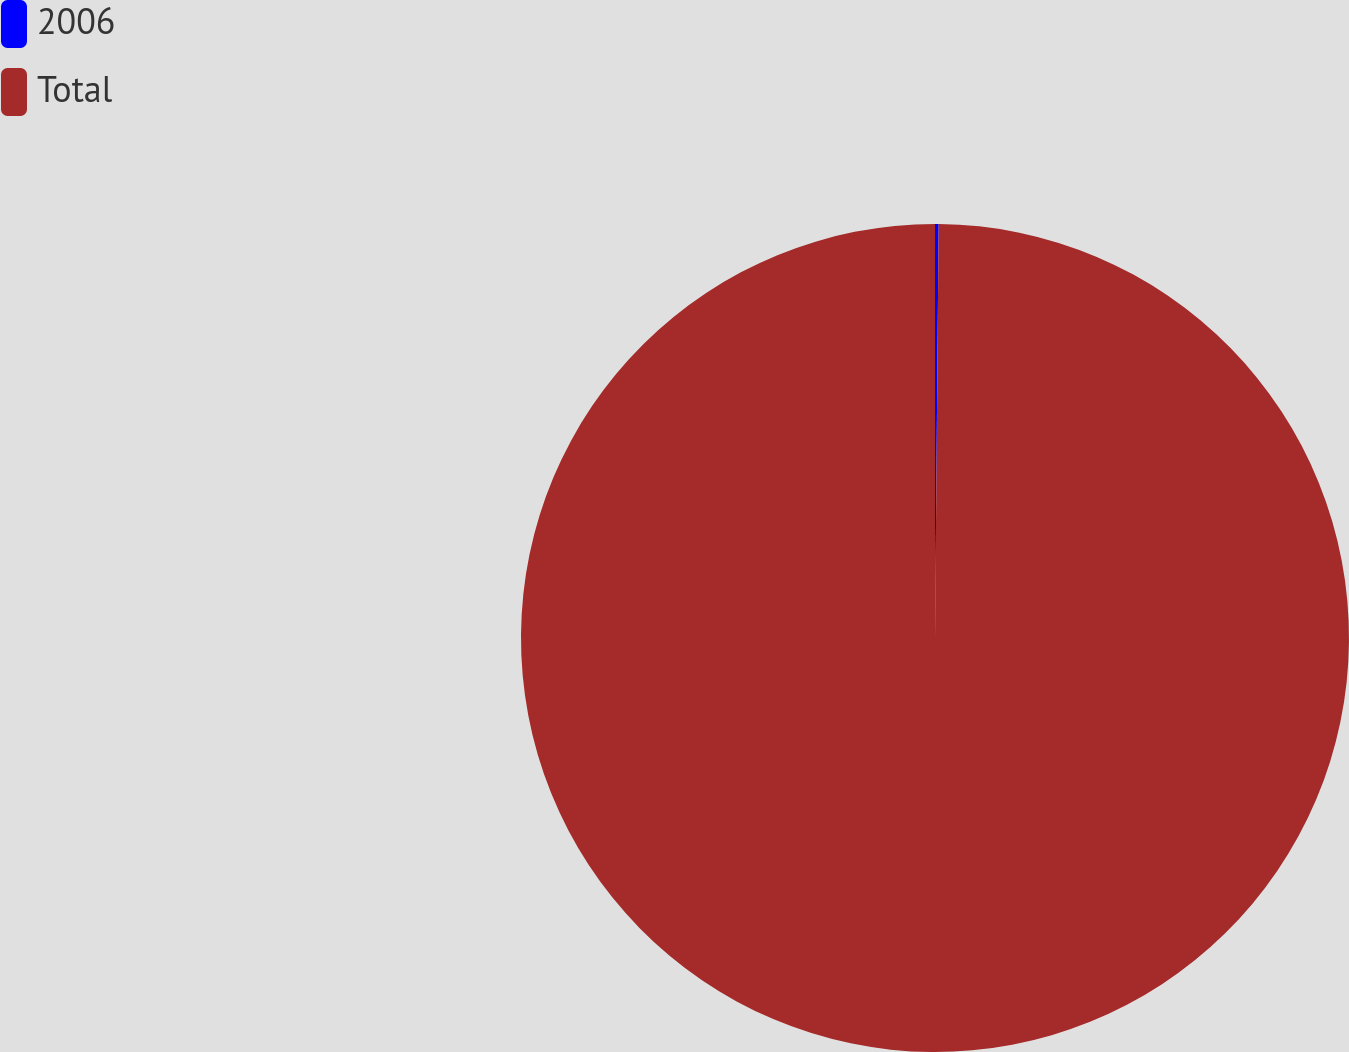Convert chart. <chart><loc_0><loc_0><loc_500><loc_500><pie_chart><fcel>2006<fcel>Total<nl><fcel>0.14%<fcel>99.86%<nl></chart> 